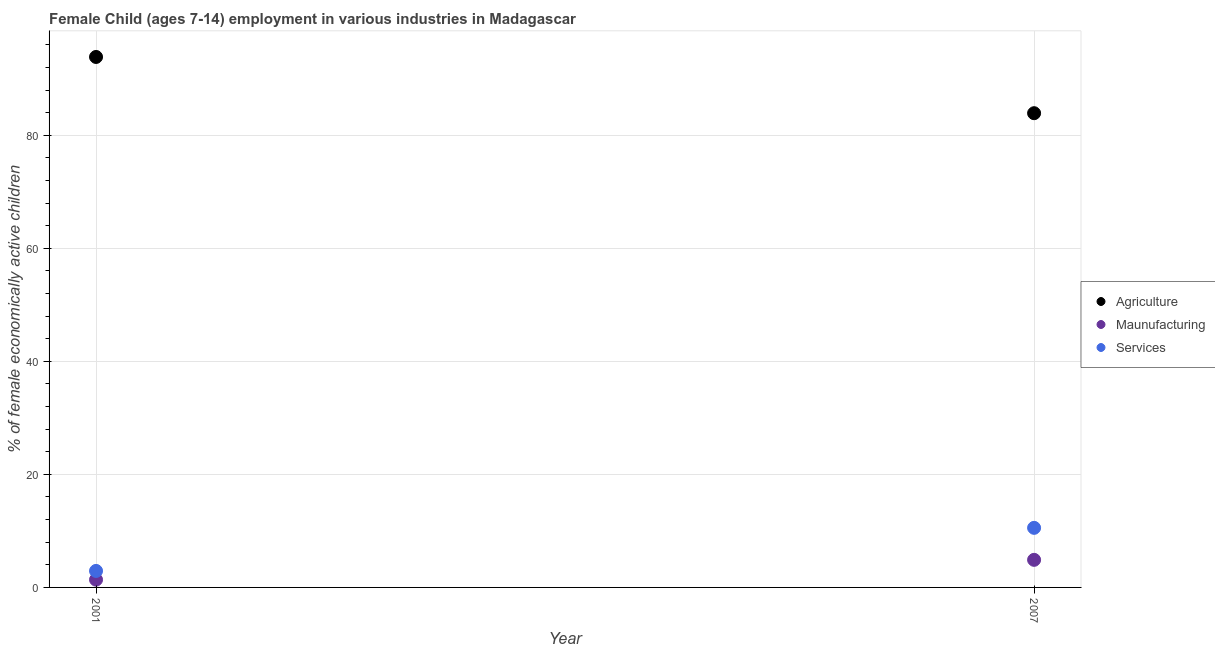Is the number of dotlines equal to the number of legend labels?
Your response must be concise. Yes. What is the percentage of economically active children in services in 2007?
Your response must be concise. 10.54. Across all years, what is the maximum percentage of economically active children in services?
Ensure brevity in your answer.  10.54. Across all years, what is the minimum percentage of economically active children in manufacturing?
Offer a terse response. 1.37. In which year was the percentage of economically active children in services minimum?
Your answer should be very brief. 2001. What is the total percentage of economically active children in manufacturing in the graph?
Give a very brief answer. 6.25. What is the difference between the percentage of economically active children in manufacturing in 2001 and that in 2007?
Provide a succinct answer. -3.51. What is the difference between the percentage of economically active children in services in 2007 and the percentage of economically active children in agriculture in 2001?
Give a very brief answer. -83.31. What is the average percentage of economically active children in agriculture per year?
Keep it short and to the point. 88.88. In the year 2007, what is the difference between the percentage of economically active children in agriculture and percentage of economically active children in services?
Your answer should be compact. 73.36. What is the ratio of the percentage of economically active children in services in 2001 to that in 2007?
Offer a very short reply. 0.28. Is the percentage of economically active children in services in 2001 less than that in 2007?
Ensure brevity in your answer.  Yes. In how many years, is the percentage of economically active children in manufacturing greater than the average percentage of economically active children in manufacturing taken over all years?
Ensure brevity in your answer.  1. Does the percentage of economically active children in manufacturing monotonically increase over the years?
Your answer should be very brief. Yes. Is the percentage of economically active children in services strictly greater than the percentage of economically active children in agriculture over the years?
Offer a terse response. No. How many years are there in the graph?
Your response must be concise. 2. What is the difference between two consecutive major ticks on the Y-axis?
Offer a terse response. 20. Does the graph contain any zero values?
Your response must be concise. No. Does the graph contain grids?
Provide a short and direct response. Yes. How many legend labels are there?
Make the answer very short. 3. What is the title of the graph?
Keep it short and to the point. Female Child (ages 7-14) employment in various industries in Madagascar. Does "Textiles and clothing" appear as one of the legend labels in the graph?
Ensure brevity in your answer.  No. What is the label or title of the Y-axis?
Provide a succinct answer. % of female economically active children. What is the % of female economically active children in Agriculture in 2001?
Offer a terse response. 93.85. What is the % of female economically active children in Maunufacturing in 2001?
Your answer should be very brief. 1.37. What is the % of female economically active children of Services in 2001?
Your answer should be compact. 2.92. What is the % of female economically active children of Agriculture in 2007?
Your answer should be very brief. 83.9. What is the % of female economically active children in Maunufacturing in 2007?
Offer a very short reply. 4.88. What is the % of female economically active children of Services in 2007?
Keep it short and to the point. 10.54. Across all years, what is the maximum % of female economically active children of Agriculture?
Give a very brief answer. 93.85. Across all years, what is the maximum % of female economically active children of Maunufacturing?
Provide a short and direct response. 4.88. Across all years, what is the maximum % of female economically active children in Services?
Keep it short and to the point. 10.54. Across all years, what is the minimum % of female economically active children in Agriculture?
Keep it short and to the point. 83.9. Across all years, what is the minimum % of female economically active children in Maunufacturing?
Provide a short and direct response. 1.37. Across all years, what is the minimum % of female economically active children in Services?
Keep it short and to the point. 2.92. What is the total % of female economically active children of Agriculture in the graph?
Your response must be concise. 177.75. What is the total % of female economically active children of Maunufacturing in the graph?
Your response must be concise. 6.25. What is the total % of female economically active children of Services in the graph?
Your response must be concise. 13.46. What is the difference between the % of female economically active children of Agriculture in 2001 and that in 2007?
Keep it short and to the point. 9.95. What is the difference between the % of female economically active children in Maunufacturing in 2001 and that in 2007?
Your answer should be compact. -3.51. What is the difference between the % of female economically active children of Services in 2001 and that in 2007?
Ensure brevity in your answer.  -7.62. What is the difference between the % of female economically active children of Agriculture in 2001 and the % of female economically active children of Maunufacturing in 2007?
Give a very brief answer. 88.97. What is the difference between the % of female economically active children of Agriculture in 2001 and the % of female economically active children of Services in 2007?
Provide a succinct answer. 83.31. What is the difference between the % of female economically active children in Maunufacturing in 2001 and the % of female economically active children in Services in 2007?
Offer a very short reply. -9.17. What is the average % of female economically active children of Agriculture per year?
Your answer should be very brief. 88.88. What is the average % of female economically active children in Maunufacturing per year?
Your response must be concise. 3.12. What is the average % of female economically active children of Services per year?
Make the answer very short. 6.73. In the year 2001, what is the difference between the % of female economically active children in Agriculture and % of female economically active children in Maunufacturing?
Offer a very short reply. 92.48. In the year 2001, what is the difference between the % of female economically active children of Agriculture and % of female economically active children of Services?
Offer a very short reply. 90.93. In the year 2001, what is the difference between the % of female economically active children in Maunufacturing and % of female economically active children in Services?
Provide a short and direct response. -1.55. In the year 2007, what is the difference between the % of female economically active children in Agriculture and % of female economically active children in Maunufacturing?
Provide a succinct answer. 79.02. In the year 2007, what is the difference between the % of female economically active children in Agriculture and % of female economically active children in Services?
Offer a terse response. 73.36. In the year 2007, what is the difference between the % of female economically active children of Maunufacturing and % of female economically active children of Services?
Your response must be concise. -5.66. What is the ratio of the % of female economically active children in Agriculture in 2001 to that in 2007?
Make the answer very short. 1.12. What is the ratio of the % of female economically active children of Maunufacturing in 2001 to that in 2007?
Provide a short and direct response. 0.28. What is the ratio of the % of female economically active children in Services in 2001 to that in 2007?
Give a very brief answer. 0.28. What is the difference between the highest and the second highest % of female economically active children of Agriculture?
Ensure brevity in your answer.  9.95. What is the difference between the highest and the second highest % of female economically active children in Maunufacturing?
Your answer should be very brief. 3.51. What is the difference between the highest and the second highest % of female economically active children of Services?
Keep it short and to the point. 7.62. What is the difference between the highest and the lowest % of female economically active children in Agriculture?
Your response must be concise. 9.95. What is the difference between the highest and the lowest % of female economically active children of Maunufacturing?
Your answer should be compact. 3.51. What is the difference between the highest and the lowest % of female economically active children of Services?
Your answer should be compact. 7.62. 